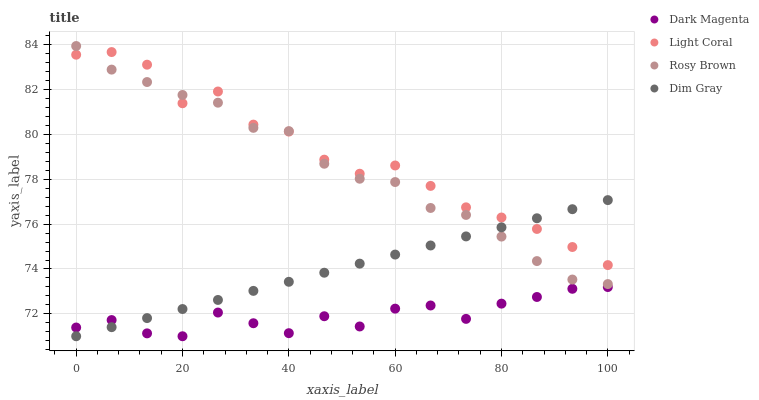Does Dark Magenta have the minimum area under the curve?
Answer yes or no. Yes. Does Light Coral have the maximum area under the curve?
Answer yes or no. Yes. Does Dim Gray have the minimum area under the curve?
Answer yes or no. No. Does Dim Gray have the maximum area under the curve?
Answer yes or no. No. Is Dim Gray the smoothest?
Answer yes or no. Yes. Is Light Coral the roughest?
Answer yes or no. Yes. Is Rosy Brown the smoothest?
Answer yes or no. No. Is Rosy Brown the roughest?
Answer yes or no. No. Does Dim Gray have the lowest value?
Answer yes or no. Yes. Does Rosy Brown have the lowest value?
Answer yes or no. No. Does Rosy Brown have the highest value?
Answer yes or no. Yes. Does Dim Gray have the highest value?
Answer yes or no. No. Is Dark Magenta less than Light Coral?
Answer yes or no. Yes. Is Rosy Brown greater than Dark Magenta?
Answer yes or no. Yes. Does Dim Gray intersect Light Coral?
Answer yes or no. Yes. Is Dim Gray less than Light Coral?
Answer yes or no. No. Is Dim Gray greater than Light Coral?
Answer yes or no. No. Does Dark Magenta intersect Light Coral?
Answer yes or no. No. 